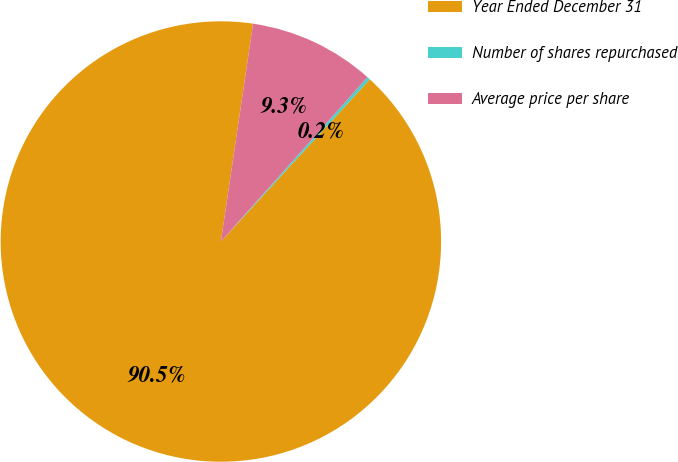Convert chart to OTSL. <chart><loc_0><loc_0><loc_500><loc_500><pie_chart><fcel>Year Ended December 31<fcel>Number of shares repurchased<fcel>Average price per share<nl><fcel>90.52%<fcel>0.23%<fcel>9.26%<nl></chart> 